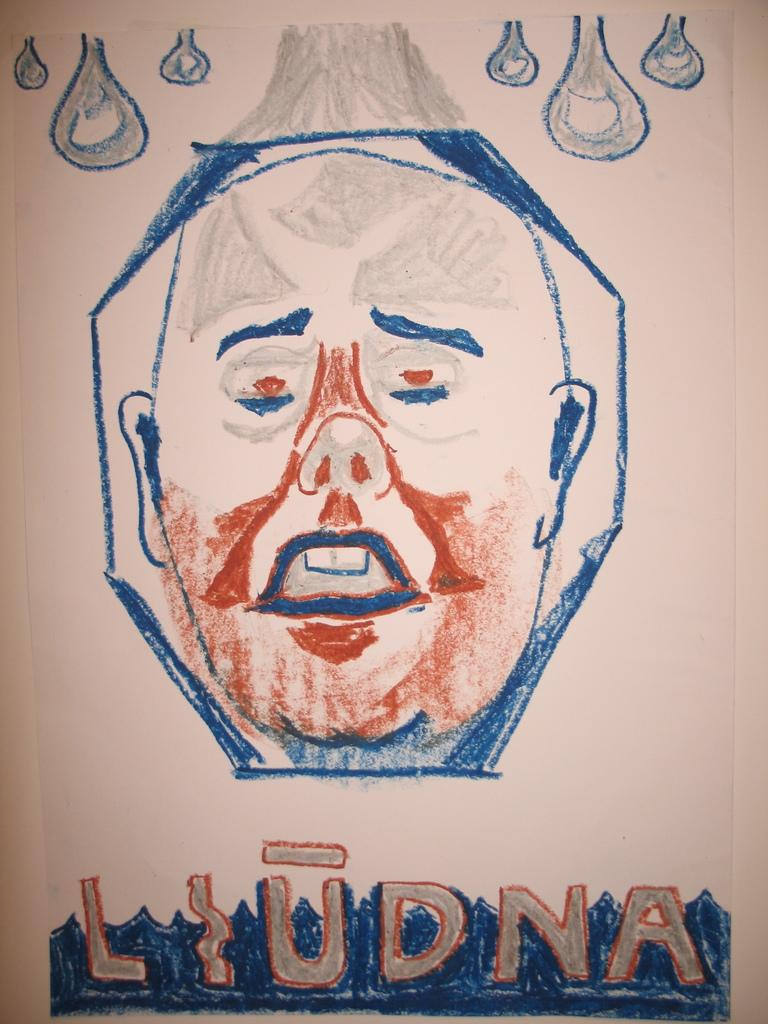What is depicted in the image? There is a drawing of a person in the image. What else can be seen in the image besides the drawing? There is text on paper in the image. What type of pets are visible in the image? There are no pets visible in the image; it only contains a drawing of a person and text on paper. What is the person's interest in the image? The image does not provide information about the person's interests. 